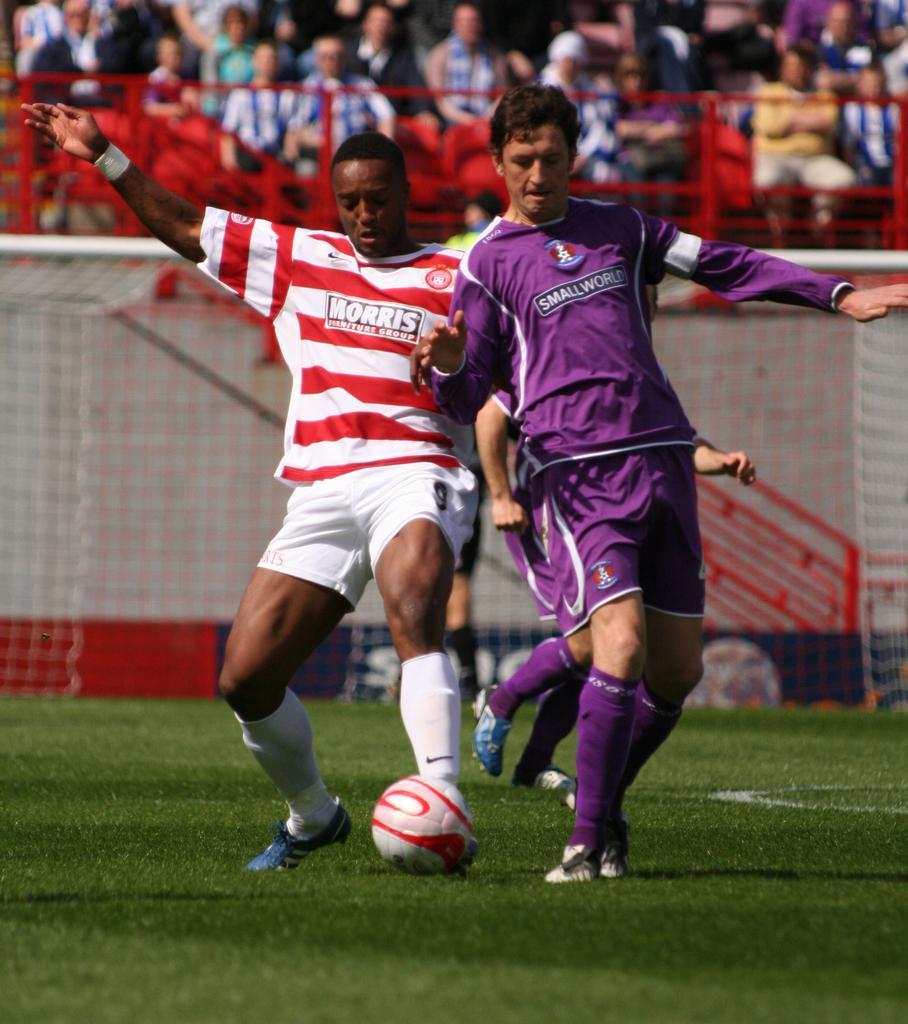Could you give a brief overview of what you see in this image? In this picture two men are playing game in the ground with ball, in the background we can see couple of people are seated on the chairs and they are watching the game. 